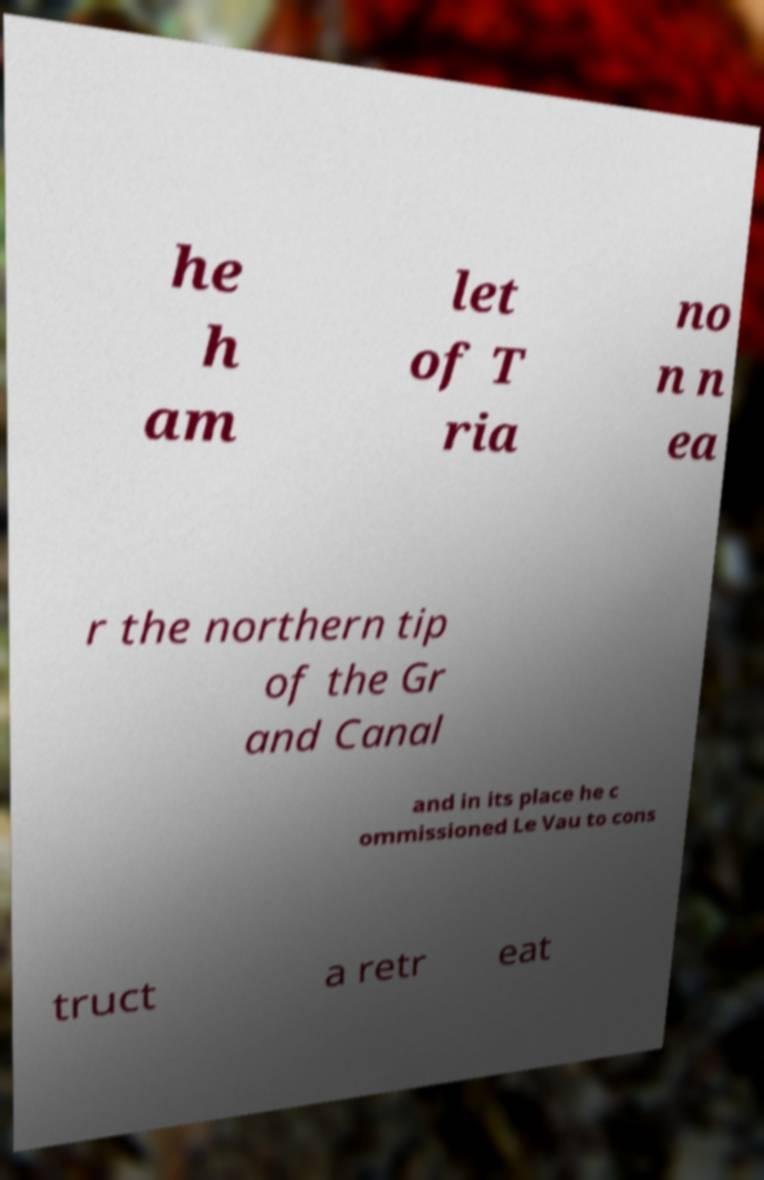Could you extract and type out the text from this image? he h am let of T ria no n n ea r the northern tip of the Gr and Canal and in its place he c ommissioned Le Vau to cons truct a retr eat 